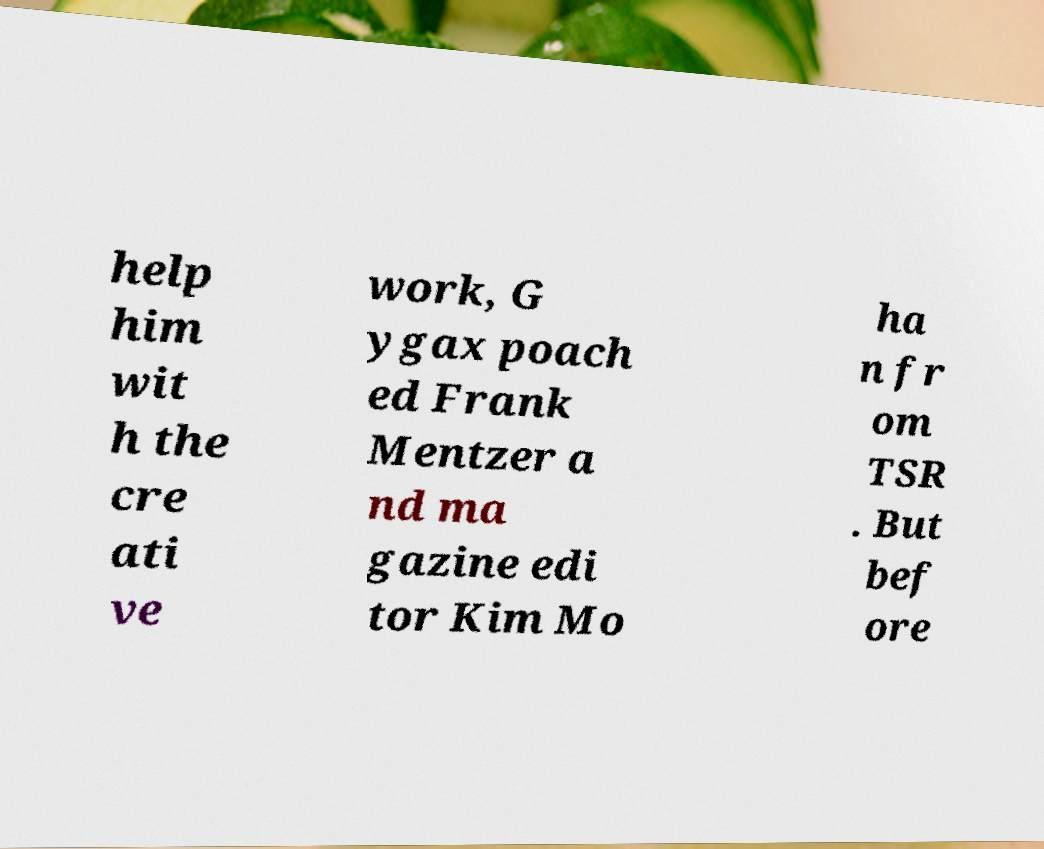Please identify and transcribe the text found in this image. help him wit h the cre ati ve work, G ygax poach ed Frank Mentzer a nd ma gazine edi tor Kim Mo ha n fr om TSR . But bef ore 